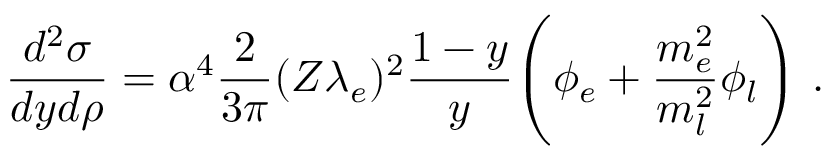Convert formula to latex. <formula><loc_0><loc_0><loc_500><loc_500>{ \frac { d ^ { 2 } \sigma } { d y d \rho } } = \alpha ^ { 4 } { \frac { 2 } { 3 \pi } } ( Z \lambda _ { e } ) ^ { 2 } { \frac { 1 - y } { y } } \left ( \phi _ { e } + { \frac { m _ { e } ^ { 2 } } { m _ { l } ^ { 2 } } } \phi _ { l } \right ) \ .</formula> 